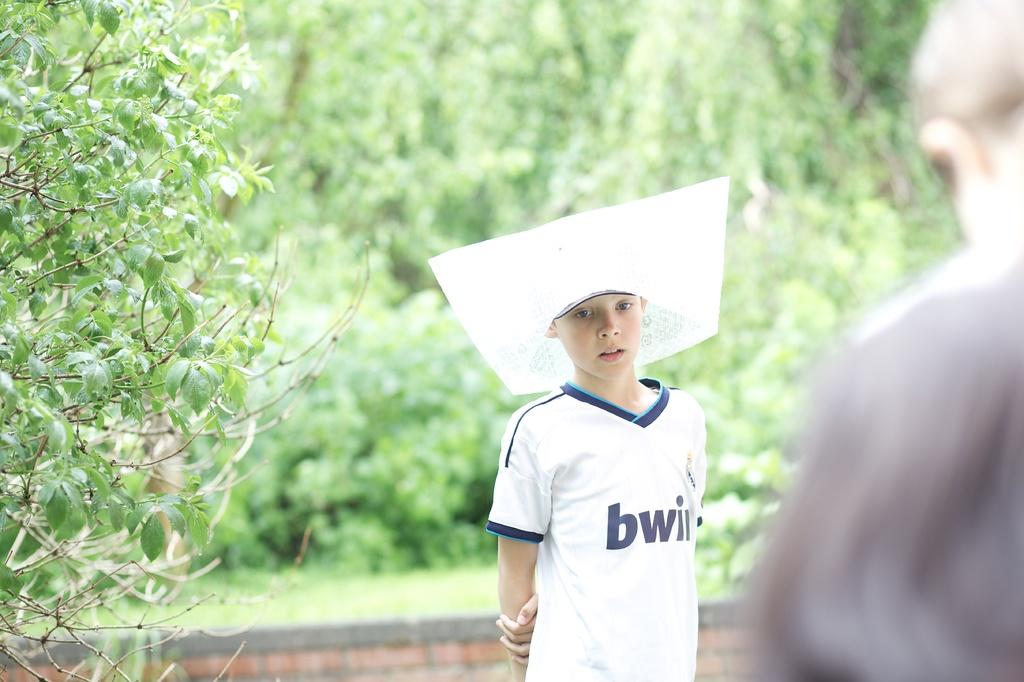What are the first two letters on the shirt?
Your answer should be compact. Bw. 